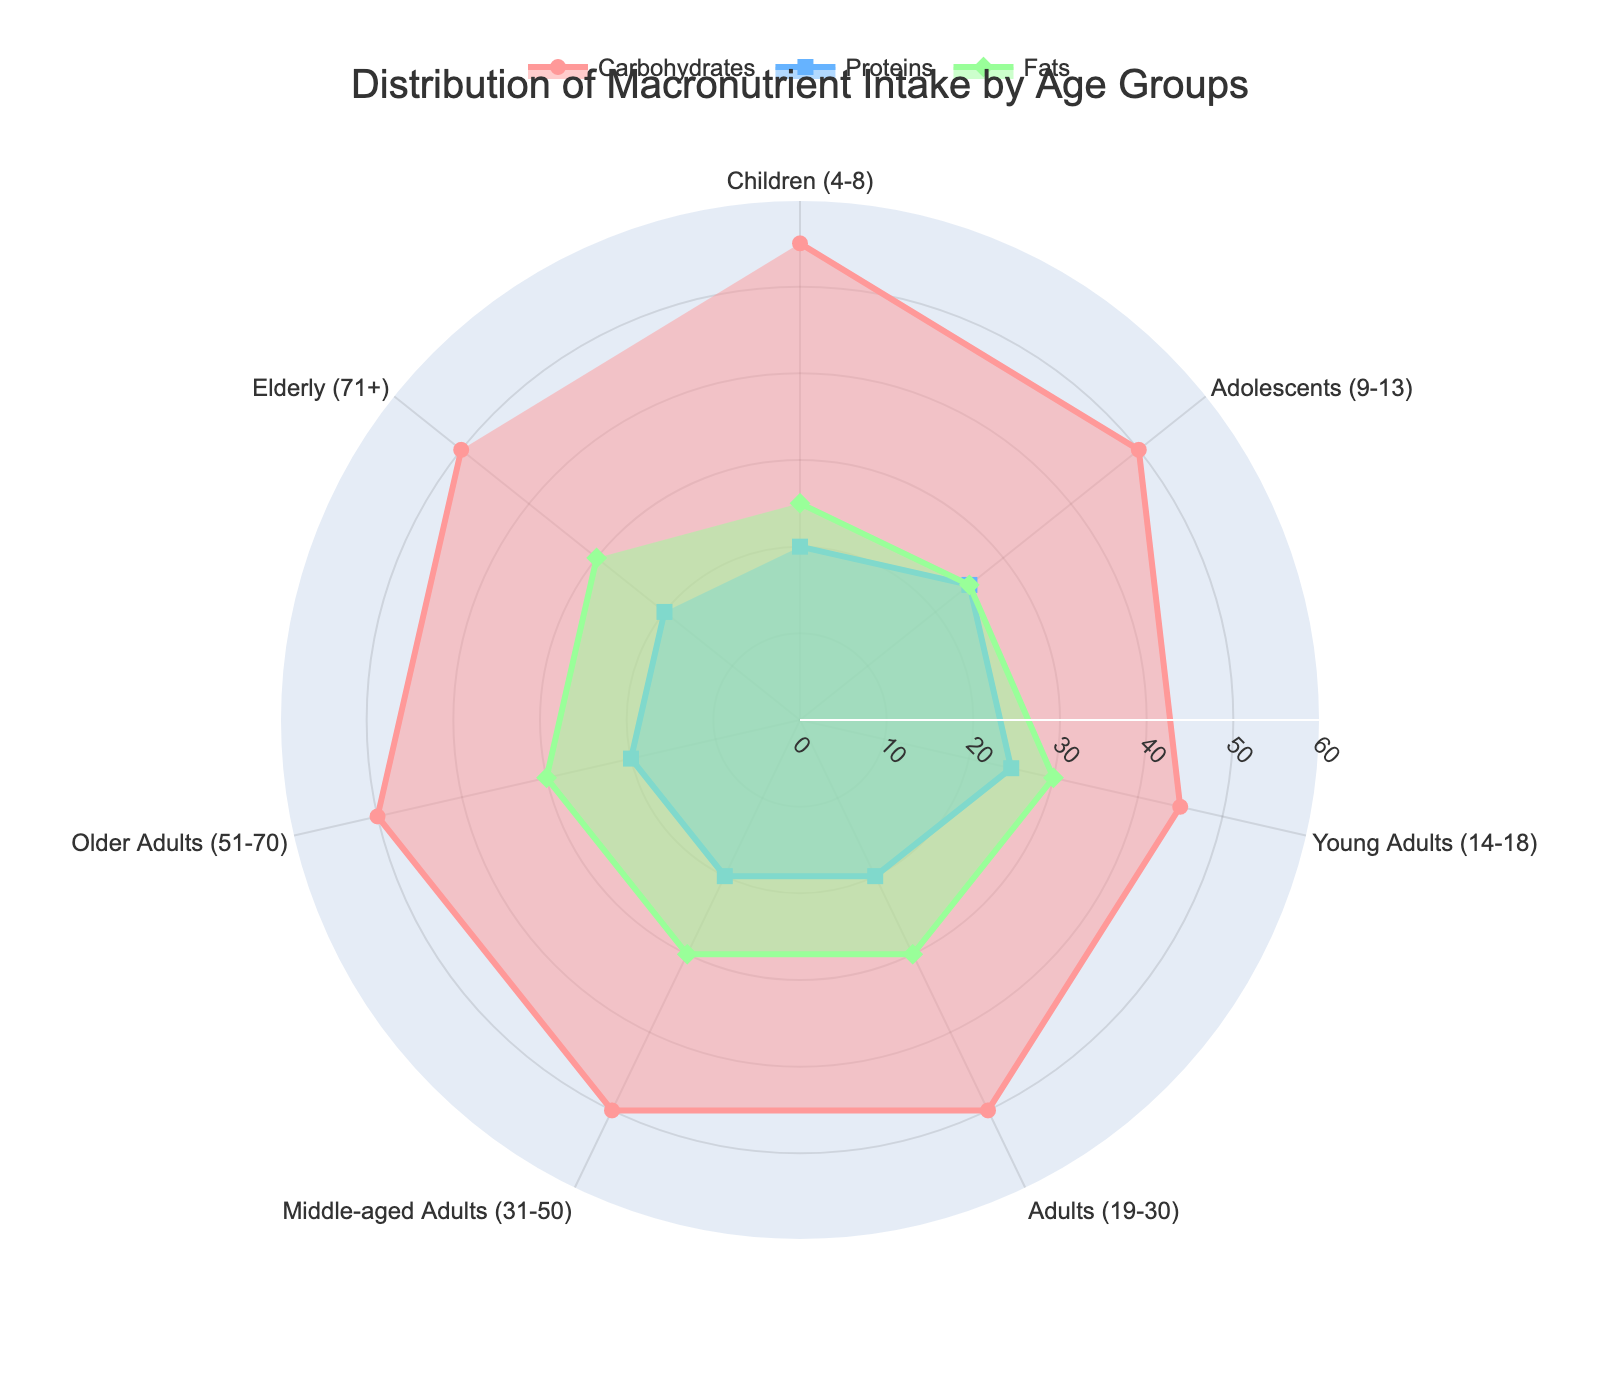What is the title of the figure? The title of the figure is displayed at the top of the radar chart. It provides a summary of what the chart represents. In this case, the title is "Distribution of Macronutrient Intake by Age Groups".
Answer: Distribution of Macronutrient Intake by Age Groups Which macronutrient has the highest percentage for Young Adults (14-18)? To find this, locate the section of the radar chart labeled "Young Adults (14-18)" and observe the data points for carbohydrates, proteins, and fats. The highest percentage corresponds to fats at 30%.
Answer: Fats What is the range of the radial axis in the figure? The radial axis is the axis that extends from the center to the edges of the radar chart. It represents the range of percentage values for macronutrients. The range starts from 0 and goes up to 60.
Answer: 0 to 60 Which age groups have the same macronutrient distribution? To determine this, look for age groups with identical values for carbohydrates, proteins, and fats. "Adults (19-30)," "Middle-aged Adults (31-50)," "Older Adults (51-70)," and "Elderly (71+)" all have 50% carbohydrates, 20% proteins, and 30% fats.
Answer: Adults (19-30), Middle-aged Adults (31-50), Older Adults (51-70), Elderly (71+) Compare the carbohydrate intake between Children (4-8) and Adolescents (9-13). For this comparison, check the values for carbohydrates for both age groups on the radar chart. Children (4-8) have 55% carbohydrates, while Adolescents (9-13) have 50%.
Answer: Children (4-8) have higher carbohydrate intake What is the sum of protein intake percentages for all age groups? Add the protein percentages for each age group: 20 (Children) + 25 (Adolescents) + 25 (Young Adults) + 20 (Adults) + 20 (Middle-aged Adults) + 20 (Older Adults) + 20 (Elderly) = 150.
Answer: 150 Which age group has the lowest protein percentage and what is it? To find the lowest protein percentage, compare the protein values of all age groups. Both Children (4-8), Adults (19-30), Middle-aged Adults (31-50), Older Adults (51-70), and Elderly (71+) have the lowest value at 20%.
Answer: Children (4-8), Adults (19-30), Middle-aged Adults (31-50), Older Adults (51-70), Elderly (71+), 20% How does the fat intake for Adolescents (9-13) compare to that of Young Adults (14-18)? Look at the percentage values for fats in these age groups. Adolescents (9-13) have 25% fat intake, while Young Adults (14-18) have 30%. Hence Young Adults have 5% more fats in their diet.
Answer: Young Adults have 5% more fats Calculate the average carbohydrate percentage across all age groups. To find the average carbohydrate percentage, sum up the carbohydrate percentages across all age groups (55 + 50 + 45 + 50 + 50 + 50 + 50) and then divide by the number of age groups which is 7: (350/7) = 50.
Answer: 50 Which macronutrient has the most even distribution across all age groups and how can you tell? Examine the radar chart to evaluate the variation in percentages for each macronutrient across all age groups. Proteins have the most even distribution, predominantly around 20-25% in all groups, indicating minimal variability.
Answer: Proteins 